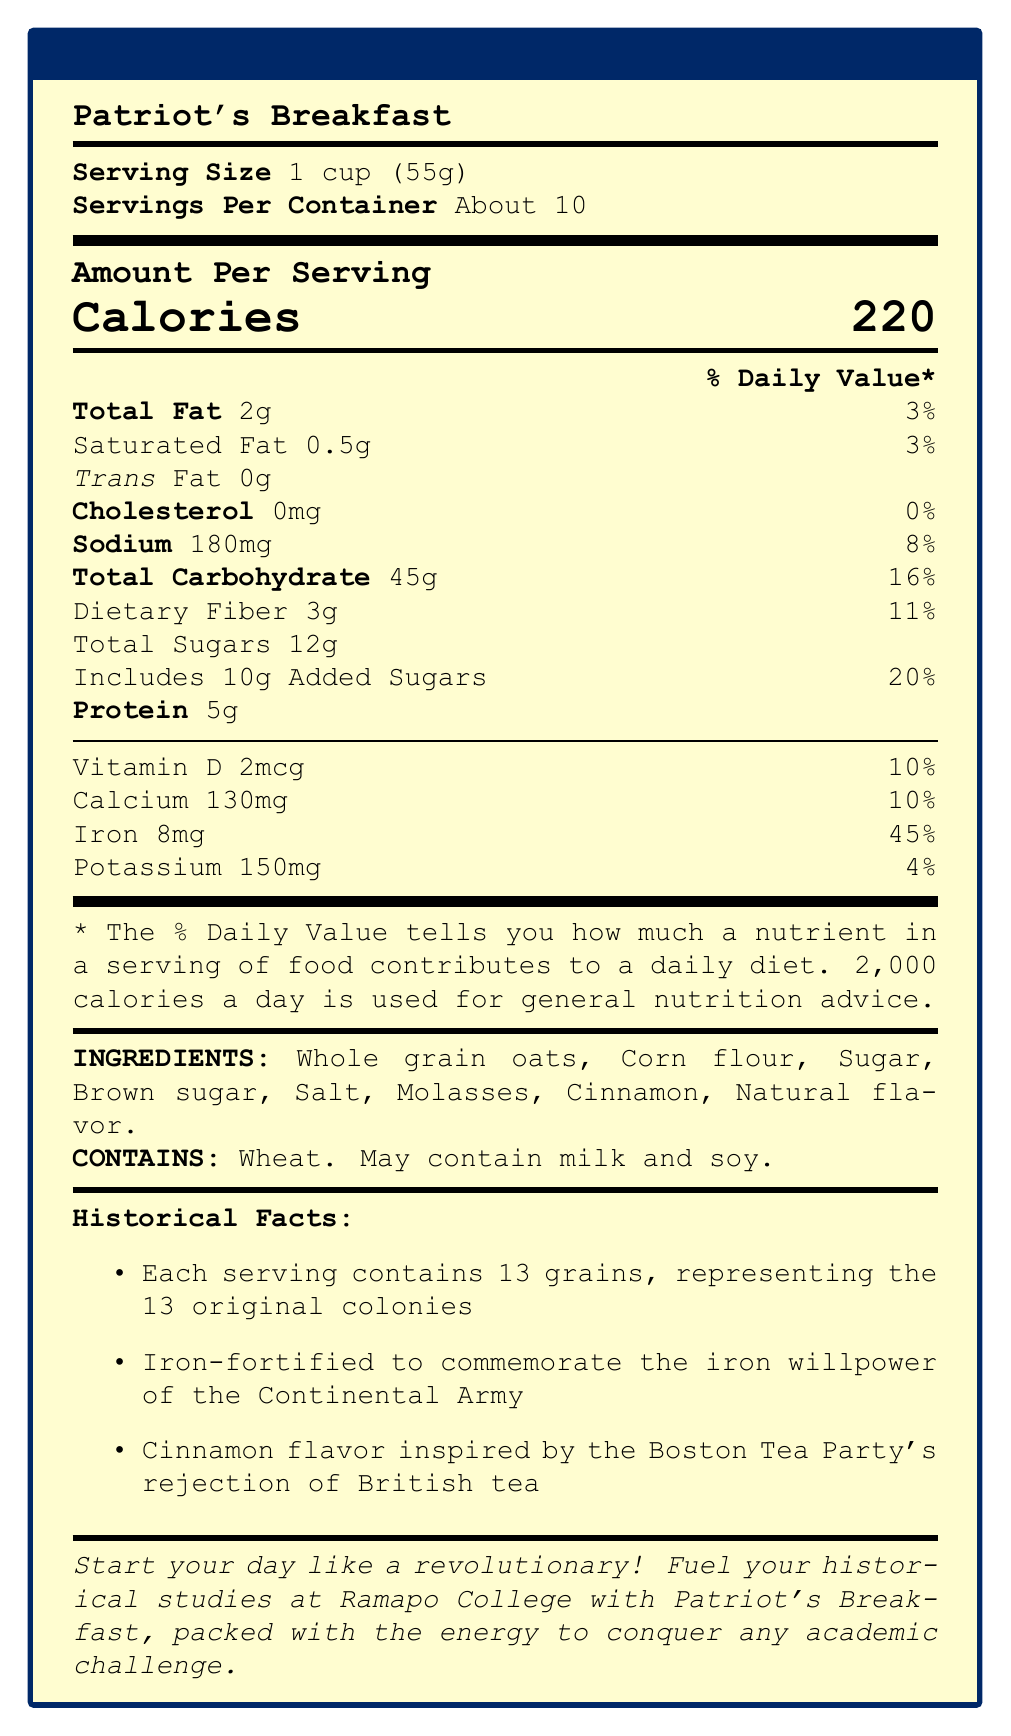what is the serving size for Patriot's Breakfast? The document explicitly states that the serving size is 1 cup (55g).
Answer: 1 cup (55g) how many servings are in each container? The document mentions that there are "About 10" servings per container.
Answer: About 10 how many calories are in one serving of Patriot's Breakfast? The document lists the calories per serving as 220.
Answer: 220 what percentage of the daily value for iron does one serving provide? One serving provides 45% of the daily value for iron.
Answer: 45% which ingredient in Patriot's Breakfast is likely responsible for its cinnamon flavor? The ingredients list includes cinnamon, which would be responsible for the cinnamon flavor.
Answer: Cinnamon how much total fat is in one serving? The document states that one serving contains 2g of total fat.
Answer: 2g what is the daily value percentage for sodium in one serving? A) 5% B) 8% C) 10% The daily value percentage for sodium in one serving is listed as 8%.
Answer: B) 8% which of the following is NOT listed as an ingredient in Patriot's Breakfast? A) Whole grain oats B) Corn flour C) Honey D) Molasses The ingredients list does not mention honey.
Answer: C) Honey does Patriot's Breakfast contain any trans fat? The document specifies that the trans fat content is 0g.
Answer: No what historical event inspired the cinnamon flavor in Patriot's Breakfast? The document states that the cinnamon flavor is inspired by the Boston Tea Party's rejection of British tea.
Answer: The Boston Tea Party is Patriot's Breakfast a good source of protein? It contains 5g of protein per serving, making it a moderate source of protein.
Answer: Yes can you eat Patriot's Breakfast if you are allergic to milk? The allergen information states that it may contain milk, so it is not definitively safe for someone with a milk allergy.
Answer: Maybe, it's unclear what are the historical facts about Patriot's Breakfast? The document lists three historical facts related to the cereal.
Answer: Each serving contains 13 grains, it is iron-fortified to commemorate the Continental Army, and the cinnamon flavor is inspired by the Boston Tea Party describe the document. This description includes all the sections and main ideas included in the document.
Answer: The document is a Nutrition Facts Label for a breakfast cereal called Patriot's Breakfast. It includes serving size, servings per container, amount per serving, calories, macronutrient information, vitamins and minerals, ingredients, allergen information, historical facts, and promotional text. The theme is related to the American Revolution, with references to the 13 original colonies, the Continental Army, and the Boston Tea Party's rejection of British tea. how much potassium is in one serving? The document specifies that one serving contains 150mg of potassium.
Answer: 150mg what is the daily value percentage for added sugars in one serving? The daily value percentage for added sugars in one serving is 20%.
Answer: 20% how much vitamin C is in one serving? The document does not provide information about the vitamin C content.
Answer: Cannot be determined 